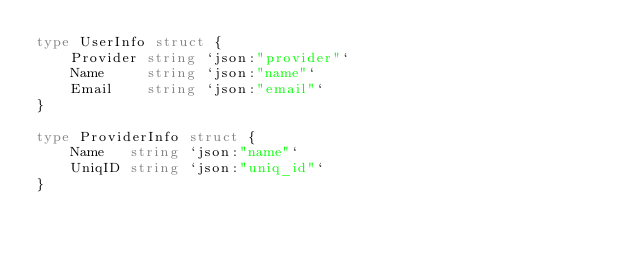Convert code to text. <code><loc_0><loc_0><loc_500><loc_500><_Go_>type UserInfo struct {
	Provider string `json:"provider"`
	Name     string `json:"name"`
	Email    string `json:"email"`
}

type ProviderInfo struct {
	Name   string `json:"name"`
	UniqID string `json:"uniq_id"`
}
</code> 